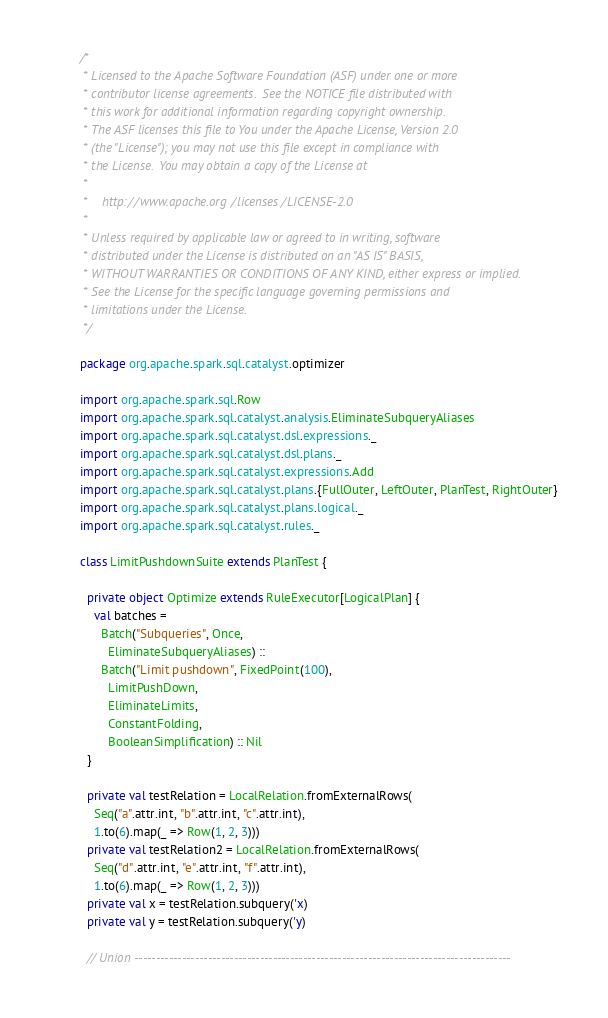Convert code to text. <code><loc_0><loc_0><loc_500><loc_500><_Scala_>/*
 * Licensed to the Apache Software Foundation (ASF) under one or more
 * contributor license agreements.  See the NOTICE file distributed with
 * this work for additional information regarding copyright ownership.
 * The ASF licenses this file to You under the Apache License, Version 2.0
 * (the "License"); you may not use this file except in compliance with
 * the License.  You may obtain a copy of the License at
 *
 *    http://www.apache.org/licenses/LICENSE-2.0
 *
 * Unless required by applicable law or agreed to in writing, software
 * distributed under the License is distributed on an "AS IS" BASIS,
 * WITHOUT WARRANTIES OR CONDITIONS OF ANY KIND, either express or implied.
 * See the License for the specific language governing permissions and
 * limitations under the License.
 */

package org.apache.spark.sql.catalyst.optimizer

import org.apache.spark.sql.Row
import org.apache.spark.sql.catalyst.analysis.EliminateSubqueryAliases
import org.apache.spark.sql.catalyst.dsl.expressions._
import org.apache.spark.sql.catalyst.dsl.plans._
import org.apache.spark.sql.catalyst.expressions.Add
import org.apache.spark.sql.catalyst.plans.{FullOuter, LeftOuter, PlanTest, RightOuter}
import org.apache.spark.sql.catalyst.plans.logical._
import org.apache.spark.sql.catalyst.rules._

class LimitPushdownSuite extends PlanTest {

  private object Optimize extends RuleExecutor[LogicalPlan] {
    val batches =
      Batch("Subqueries", Once,
        EliminateSubqueryAliases) ::
      Batch("Limit pushdown", FixedPoint(100),
        LimitPushDown,
        EliminateLimits,
        ConstantFolding,
        BooleanSimplification) :: Nil
  }

  private val testRelation = LocalRelation.fromExternalRows(
    Seq("a".attr.int, "b".attr.int, "c".attr.int),
    1.to(6).map(_ => Row(1, 2, 3)))
  private val testRelation2 = LocalRelation.fromExternalRows(
    Seq("d".attr.int, "e".attr.int, "f".attr.int),
    1.to(6).map(_ => Row(1, 2, 3)))
  private val x = testRelation.subquery('x)
  private val y = testRelation.subquery('y)

  // Union ---------------------------------------------------------------------------------------
</code> 